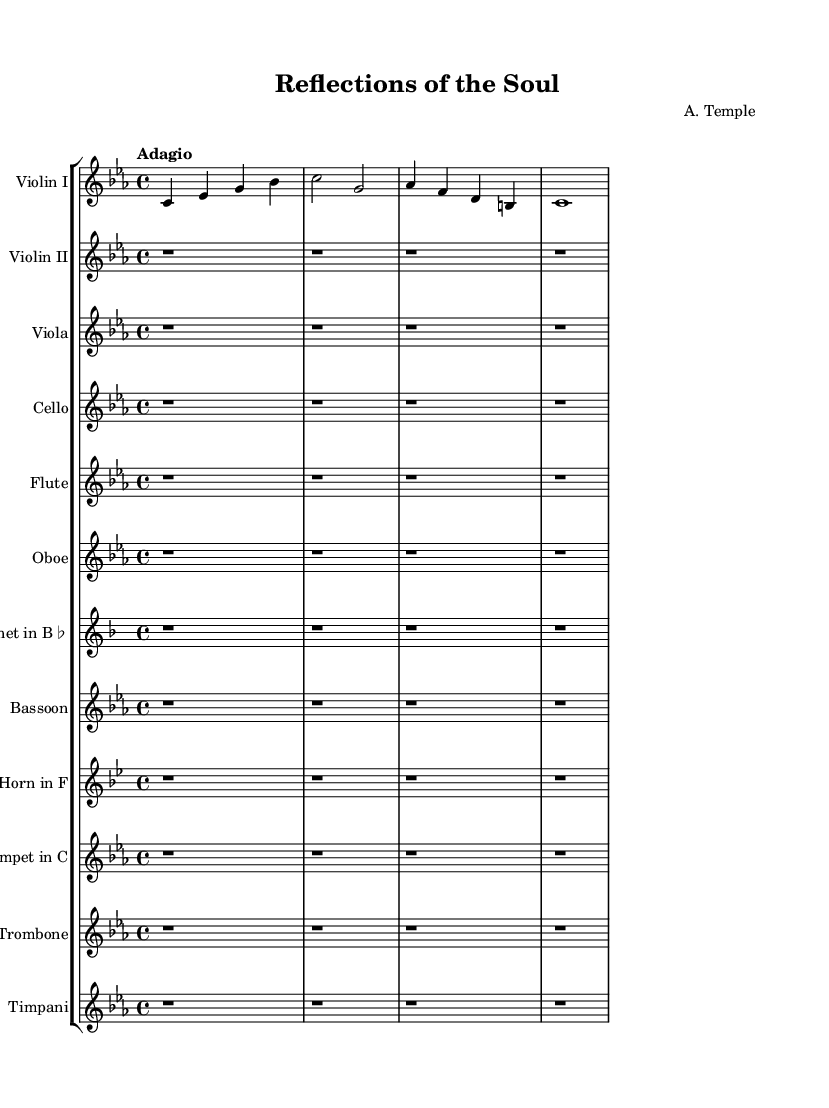What is the key signature of this music? The key signature is C minor, which includes three flats indicated by the presence of the B♭, E♭, and A♭. This can be determined by looking at the left side of the sheet music where the key signature is displayed.
Answer: C minor What is the time signature of this music? The time signature is 4/4, which is indicated at the beginning of the staff. This means there are four beats in each measure and the quarter note gets one beat.
Answer: 4/4 What is the tempo marking for this piece? The tempo marking is "Adagio," which suggests that the music should be played slowly and with a relaxed feel. This is noted prominently at the beginning of the score.
Answer: Adagio How many measures are present in the given music? There are five measures present in the provided excerpt, as counted by the vertical lines that separate the measures.
Answer: 5 What instruments are featured in this symphony? The instruments featured include Violin I, Violin II, Viola, Cello, Flute, Oboe, Clarinet, Bassoon, Horn, Trumpet, Trombone, and Timpani. They are listed at the beginning of each staff in the score.
Answer: Violin I, Violin II, Viola, Cello, Flute, Oboe, Clarinet, Bassoon, Horn, Trumpet, Trombone, Timpani What is the primary mood suggested by the tempo and key of this symphony? The combination of the slow tempo (Adagio) and the key of C minor typically conveys a melancholic or introspective mood, often associated with deep emotional expression. This interpretation can be derived from both the tempo marking and the characteristics of the key.
Answer: Introspective 